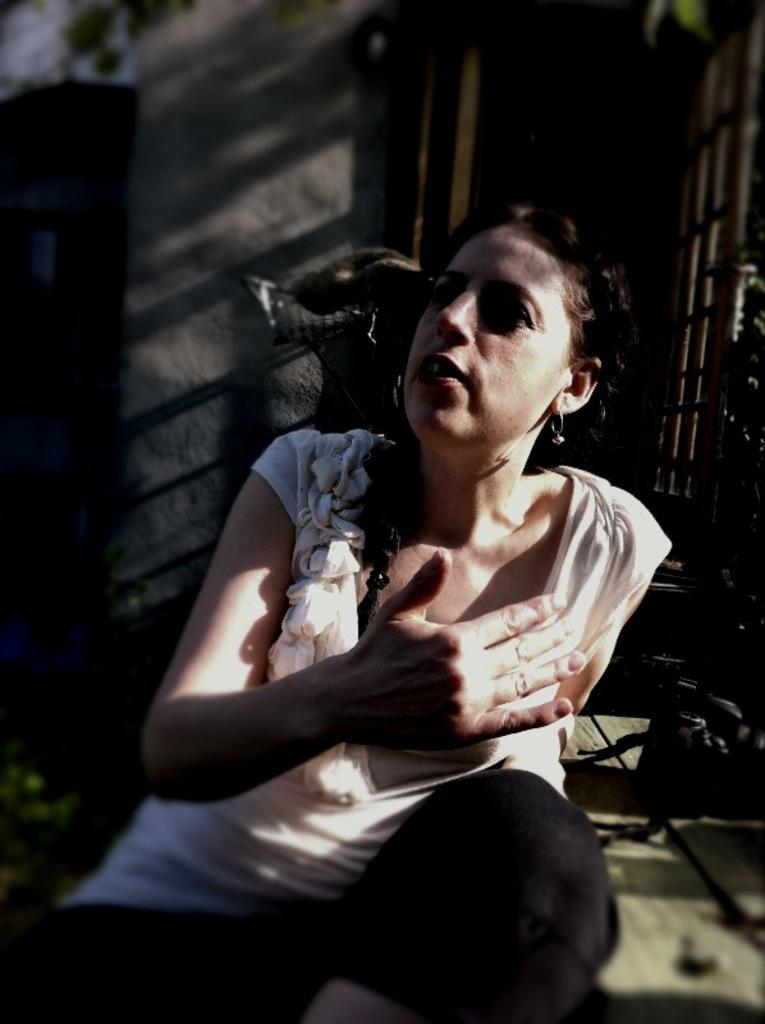What is the woman in the image doing? The woman is sitting on the floor in the image. What objects are near the woman? There are shoes beside the woman. What can be seen at the back of the image? There is a door at the back side of the image. What is next to the door? There is a wall beside the door. What type of silver material can be seen on the woman's shoes in the image? There is no silver material mentioned or visible on the shoes in the image. 